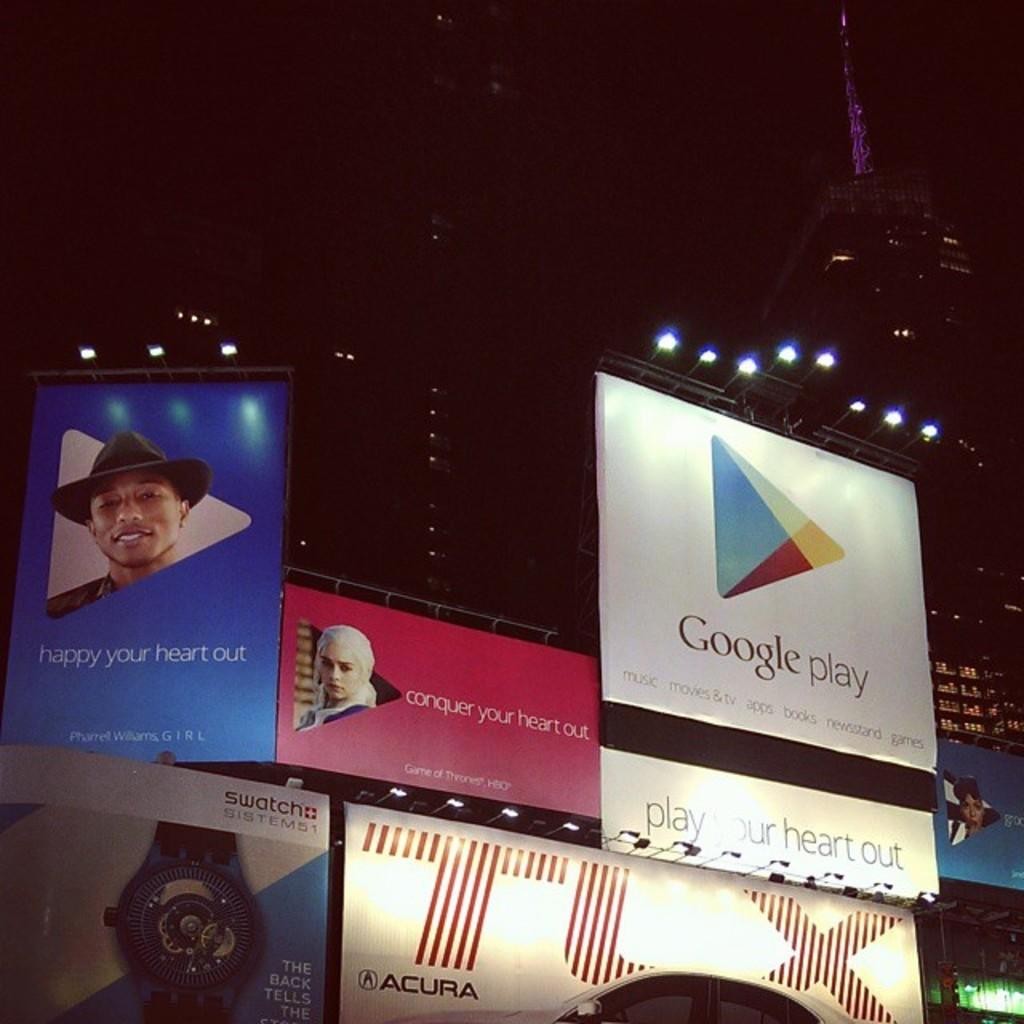<image>
Share a concise interpretation of the image provided. A large group of billboards in a stadium including one for Google play. 